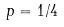Convert formula to latex. <formula><loc_0><loc_0><loc_500><loc_500>p = 1 / 4</formula> 